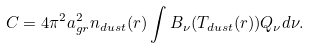<formula> <loc_0><loc_0><loc_500><loc_500>C = 4 \pi ^ { 2 } a ^ { 2 } _ { g r } n _ { d u s t } ( r ) \int B _ { \nu } ( T _ { d u s t } ( r ) ) Q _ { \nu } d \nu .</formula> 